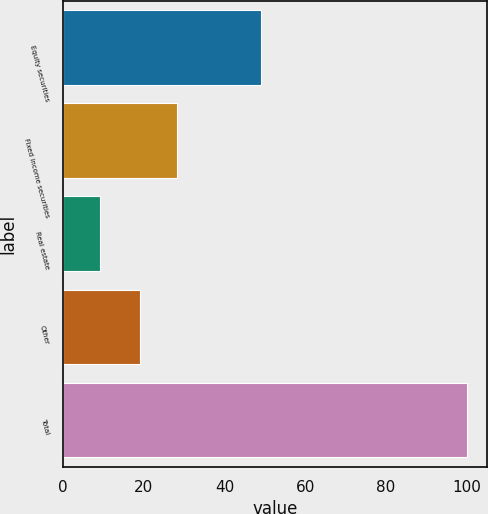Convert chart. <chart><loc_0><loc_0><loc_500><loc_500><bar_chart><fcel>Equity securities<fcel>Fixed income securities<fcel>Real estate<fcel>Other<fcel>Total<nl><fcel>49<fcel>28.1<fcel>9<fcel>19<fcel>100<nl></chart> 